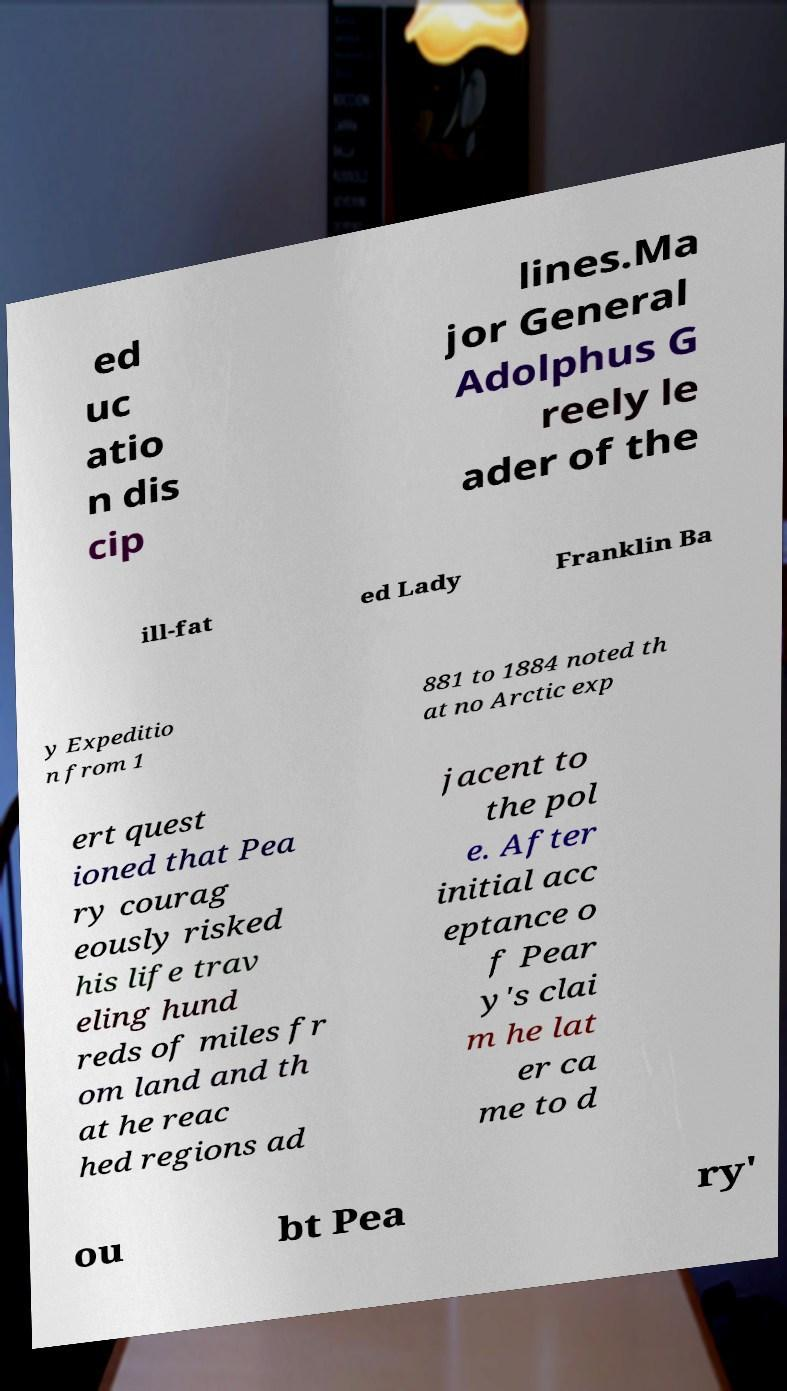For documentation purposes, I need the text within this image transcribed. Could you provide that? ed uc atio n dis cip lines.Ma jor General Adolphus G reely le ader of the ill-fat ed Lady Franklin Ba y Expeditio n from 1 881 to 1884 noted th at no Arctic exp ert quest ioned that Pea ry courag eously risked his life trav eling hund reds of miles fr om land and th at he reac hed regions ad jacent to the pol e. After initial acc eptance o f Pear y's clai m he lat er ca me to d ou bt Pea ry' 